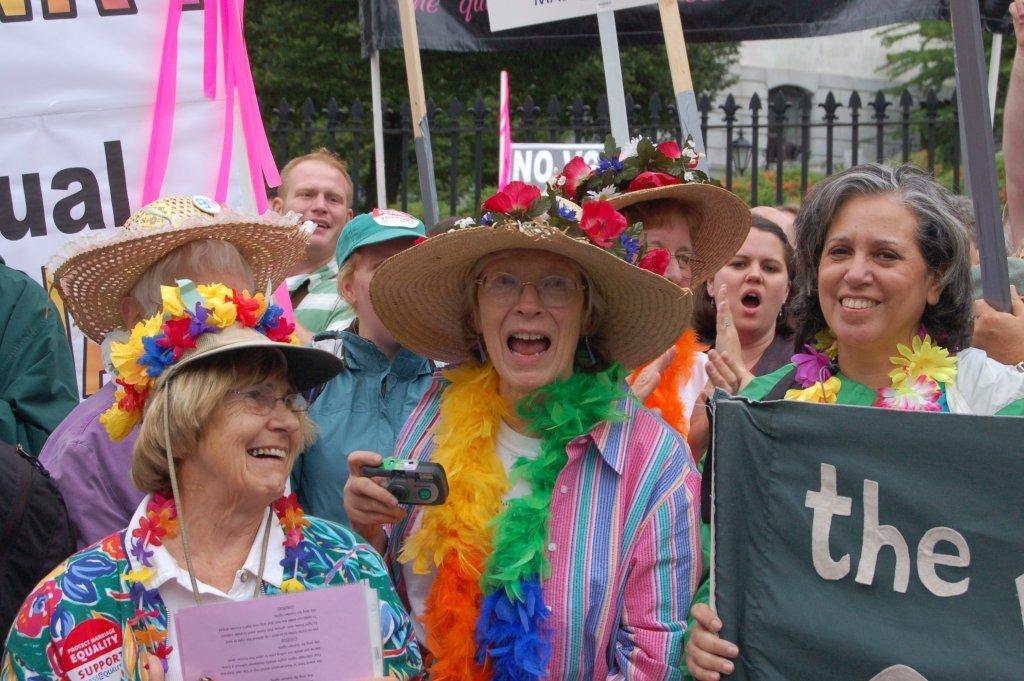Can you describe this image briefly? In this image, we can see some people standing and we can see some posters, we can see the fence and there are some green trees. 